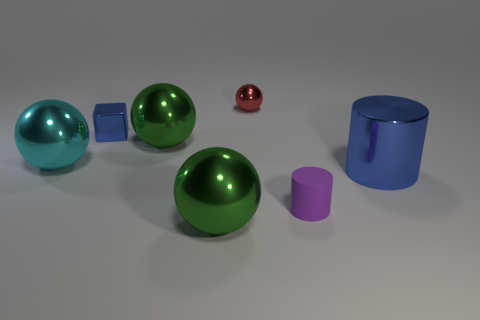Subtract all cyan spheres. How many spheres are left? 3 Subtract all tiny red metal spheres. How many spheres are left? 3 Add 1 large cyan rubber objects. How many objects exist? 8 Subtract all cubes. How many objects are left? 6 Subtract 3 balls. How many balls are left? 1 Subtract 0 cyan cylinders. How many objects are left? 7 Subtract all blue balls. Subtract all blue cylinders. How many balls are left? 4 Subtract all yellow cylinders. How many green balls are left? 2 Subtract all tiny red shiny objects. Subtract all blue shiny cubes. How many objects are left? 5 Add 1 blue cylinders. How many blue cylinders are left? 2 